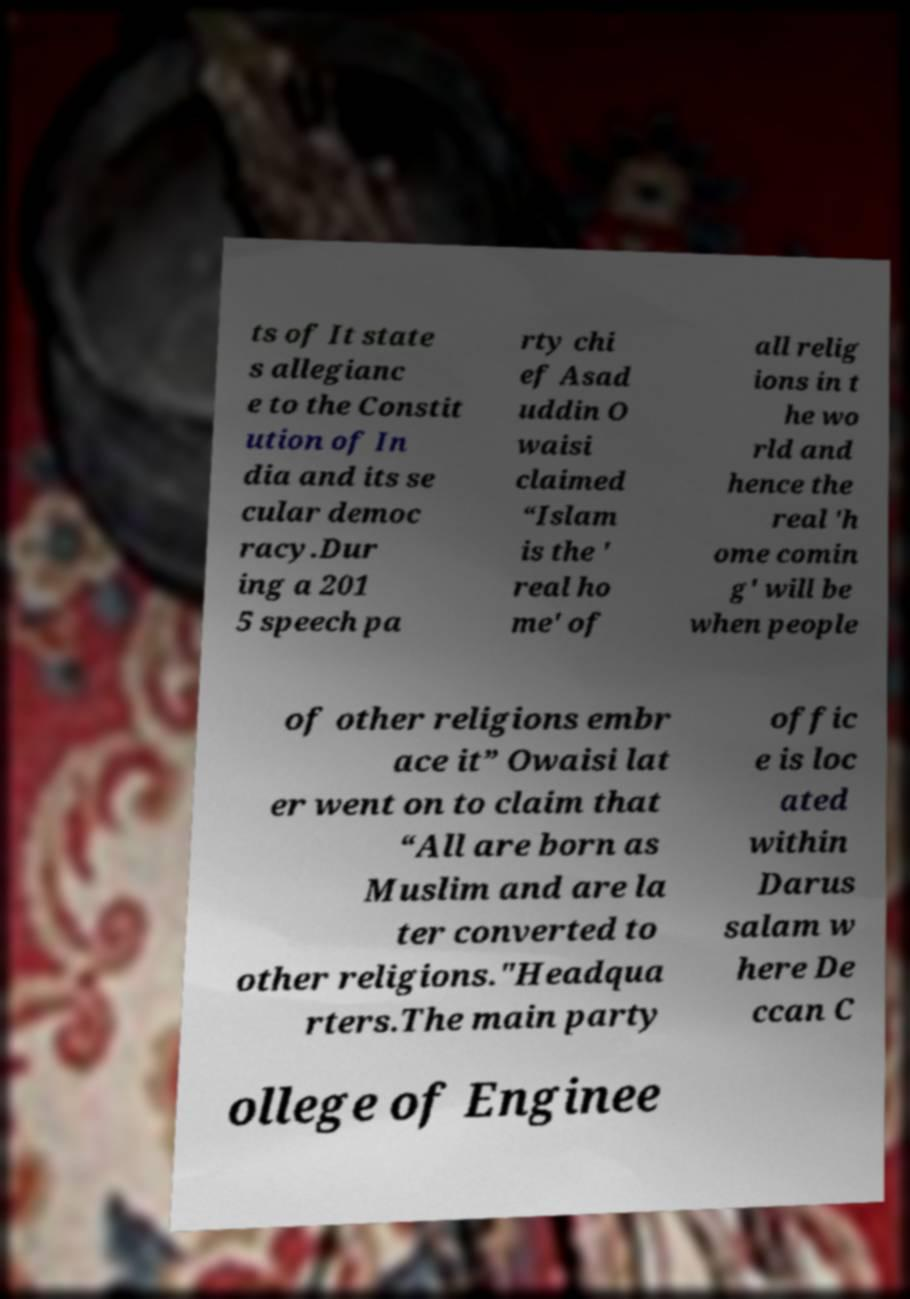For documentation purposes, I need the text within this image transcribed. Could you provide that? ts of It state s allegianc e to the Constit ution of In dia and its se cular democ racy.Dur ing a 201 5 speech pa rty chi ef Asad uddin O waisi claimed “Islam is the ' real ho me' of all relig ions in t he wo rld and hence the real 'h ome comin g' will be when people of other religions embr ace it” Owaisi lat er went on to claim that “All are born as Muslim and are la ter converted to other religions."Headqua rters.The main party offic e is loc ated within Darus salam w here De ccan C ollege of Enginee 